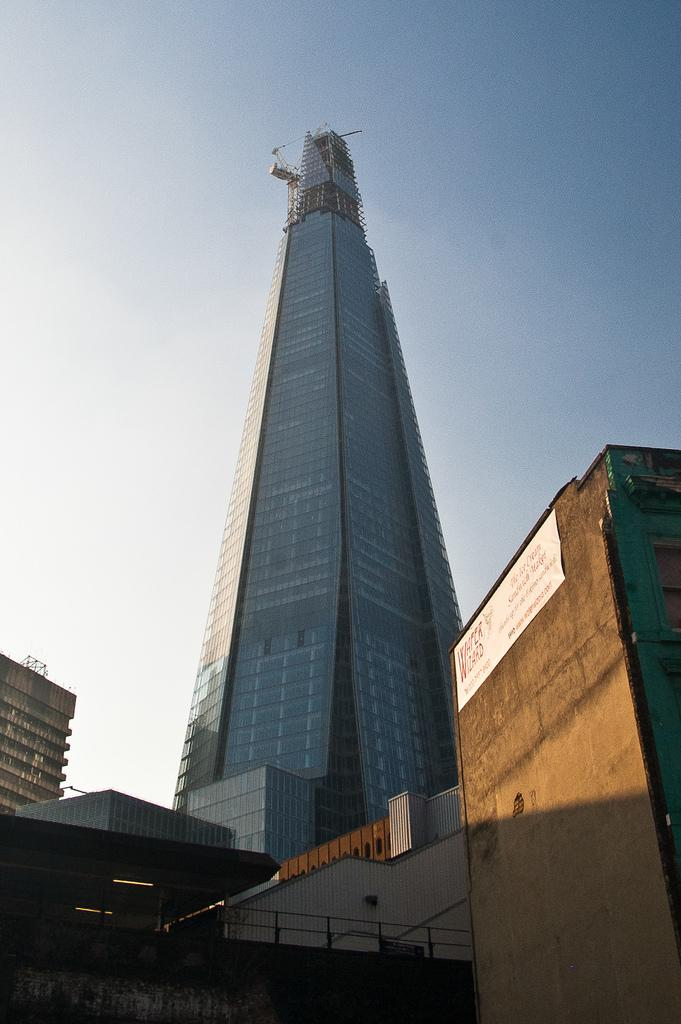What is the main structure in the image? There is a tower in the image. What other structures can be seen in the image? There are buildings in the image. What is visible in the background of the image? The sky is visible in the image. What type of selection process is taking place in the image? There is no indication of a selection process in the image; it primarily features a tower and other buildings. 